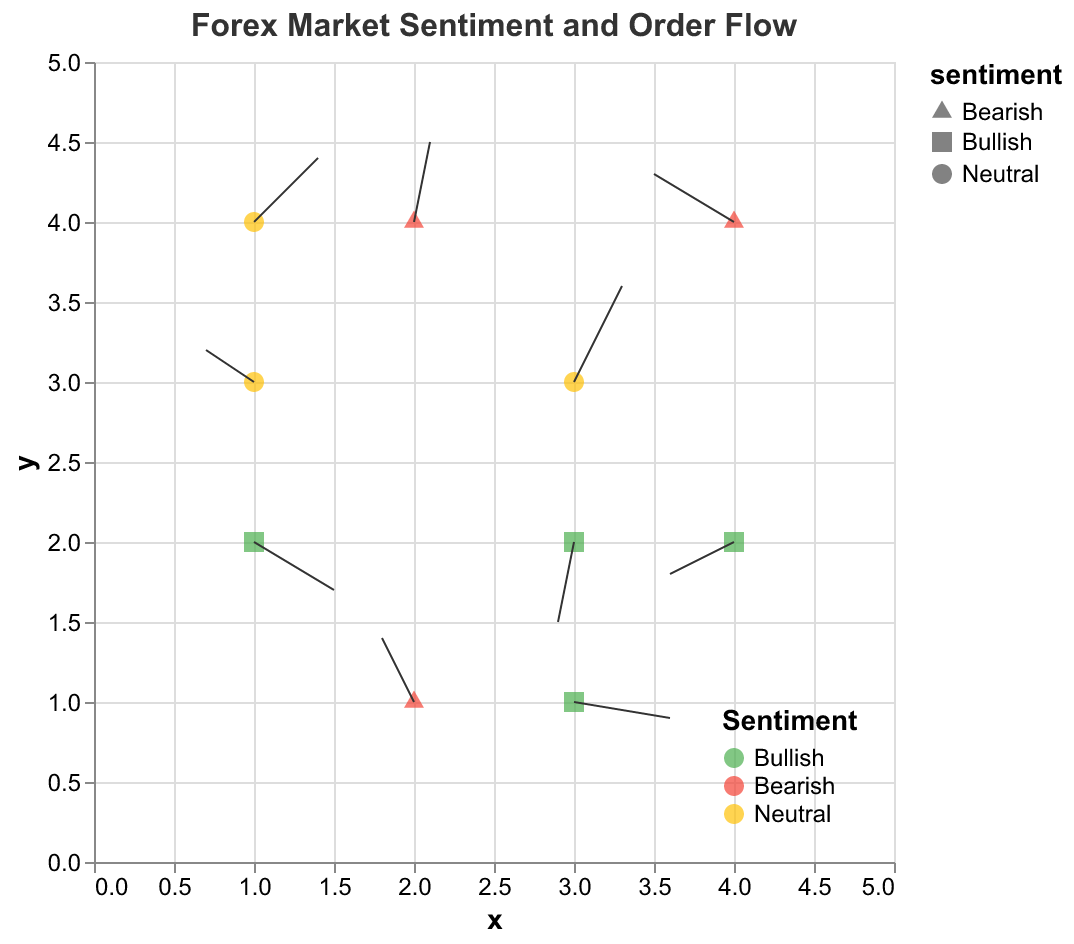What's the title of the plot? The title is usually displayed at the top of the plot. In this case, it is "Forex Market Sentiment and Order Flow".
Answer: Forex Market Sentiment and Order Flow How many data points are shown in the plot? By counting each unique pair at different (x, y) positions in the data, we can see that there are 10 data points.
Answer: 10 Which sentiment has the color green? By examining the legend, we can see that the sentiment with the green color is Bullish.
Answer: Bullish Which currency pair at position (3, 2) has a Bullish sentiment? Locate the point at position (3, 2) on the plot, and check the tooltip or legend information, indicating the pair as GBP/USD which has a Bullish sentiment.
Answer: GBP/USD Compare the arrows at position (1, 4) and (3, 3). Which one has a larger resultant vector length? To determine the resultant vector length, calculate the vector magnitude √(u^2 + v^2) for both. For (1, 4) with (0.4, 0.4), it’s √(0.4^2 + 0.4^2) = √(0.16 + 0.16) = √0.32 ≈ 0.57. For (3, 3) with (0.3, 0.6), it’s √(0.3^2 + 0.6^2) = √(0.09 + 0.36) = √0.45 ≈ 0.67. The larger magnitude is 0.67.
Answer: Position (3, 3) What is the average x-component (u) of the vectors where sentiment is Neutral? There are three Neutral points: (3, 3) [u=0.3], (1, 3) [u=-0.3], (1, 4) [u=0.4]. The average u is (0.3 - 0.3 + 0.4) / 3 ≈ 0.13.
Answer: 0.13 Which sentiment has more data points, Bullish or Bearish? By counting the data points for each sentiment as indicated by the legend colors, Bullish has 4 points (EUR/USD, AUD/NZD, USD/CAD, GBP/USD) and Bearish has 3 points (GBP/JPY, CAD/JPY, NZD/JPY). Bullish has more data points.
Answer: Bullish What is the direction of the vector at position (2, 1) and which currency pair does it represent? The coordinates (2, 1) have a vector of (-0.2, 0.4). The direction is towards the left and upward, representing the currency pair GBP/JPY as indicated by the tooltip.
Answer: Left and upward, GBP/JPY What shape is used to represent the Bearish sentiment? By looking at the legend, it is apparent that Bearish sentiment is represented by squares.
Answer: Square 